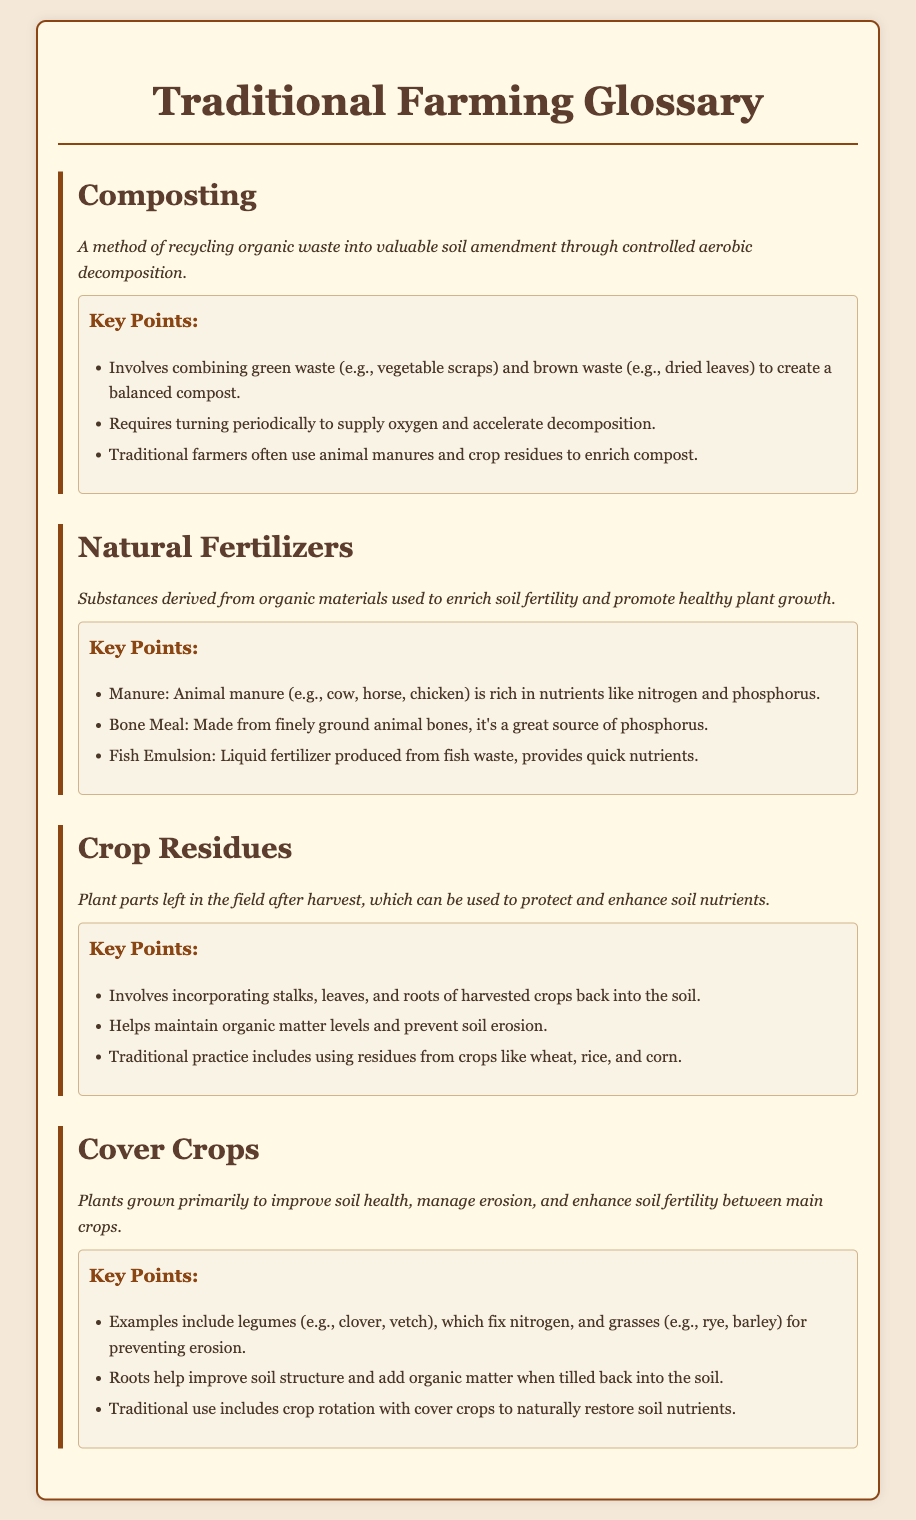What is composting? Composting is defined as a method of recycling organic waste into valuable soil amendment through controlled aerobic decomposition.
Answer: A method of recycling organic waste What are natural fertilizers? Natural fertilizers are substances derived from organic materials used to enrich soil fertility and promote healthy plant growth.
Answer: Substances derived from organic materials What type of waste is used in composting? The document mentions that composting involves combining green waste and brown waste to create compost.
Answer: Green waste and brown waste Which crop residues are traditionally used? The document lists traditional crop residues including those from crops like wheat, rice, and corn.
Answer: Wheat, rice, and corn What do cover crops primarily improve? Cover crops are grown primarily to improve soil health, manage erosion, and enhance soil fertility.
Answer: Soil health How do legumes in cover crops benefit the soil? The document states that legumes, such as clover and vetch, fix nitrogen in the soil.
Answer: Fix nitrogen What is an example of a natural fertilizer? Examples of natural fertilizers include manure, bone meal, and fish emulsion.
Answer: Manure Why is turning the compost periodic? Turning compost periodically is necessary to supply oxygen and accelerate decomposition.
Answer: Supply oxygen and accelerate decomposition 